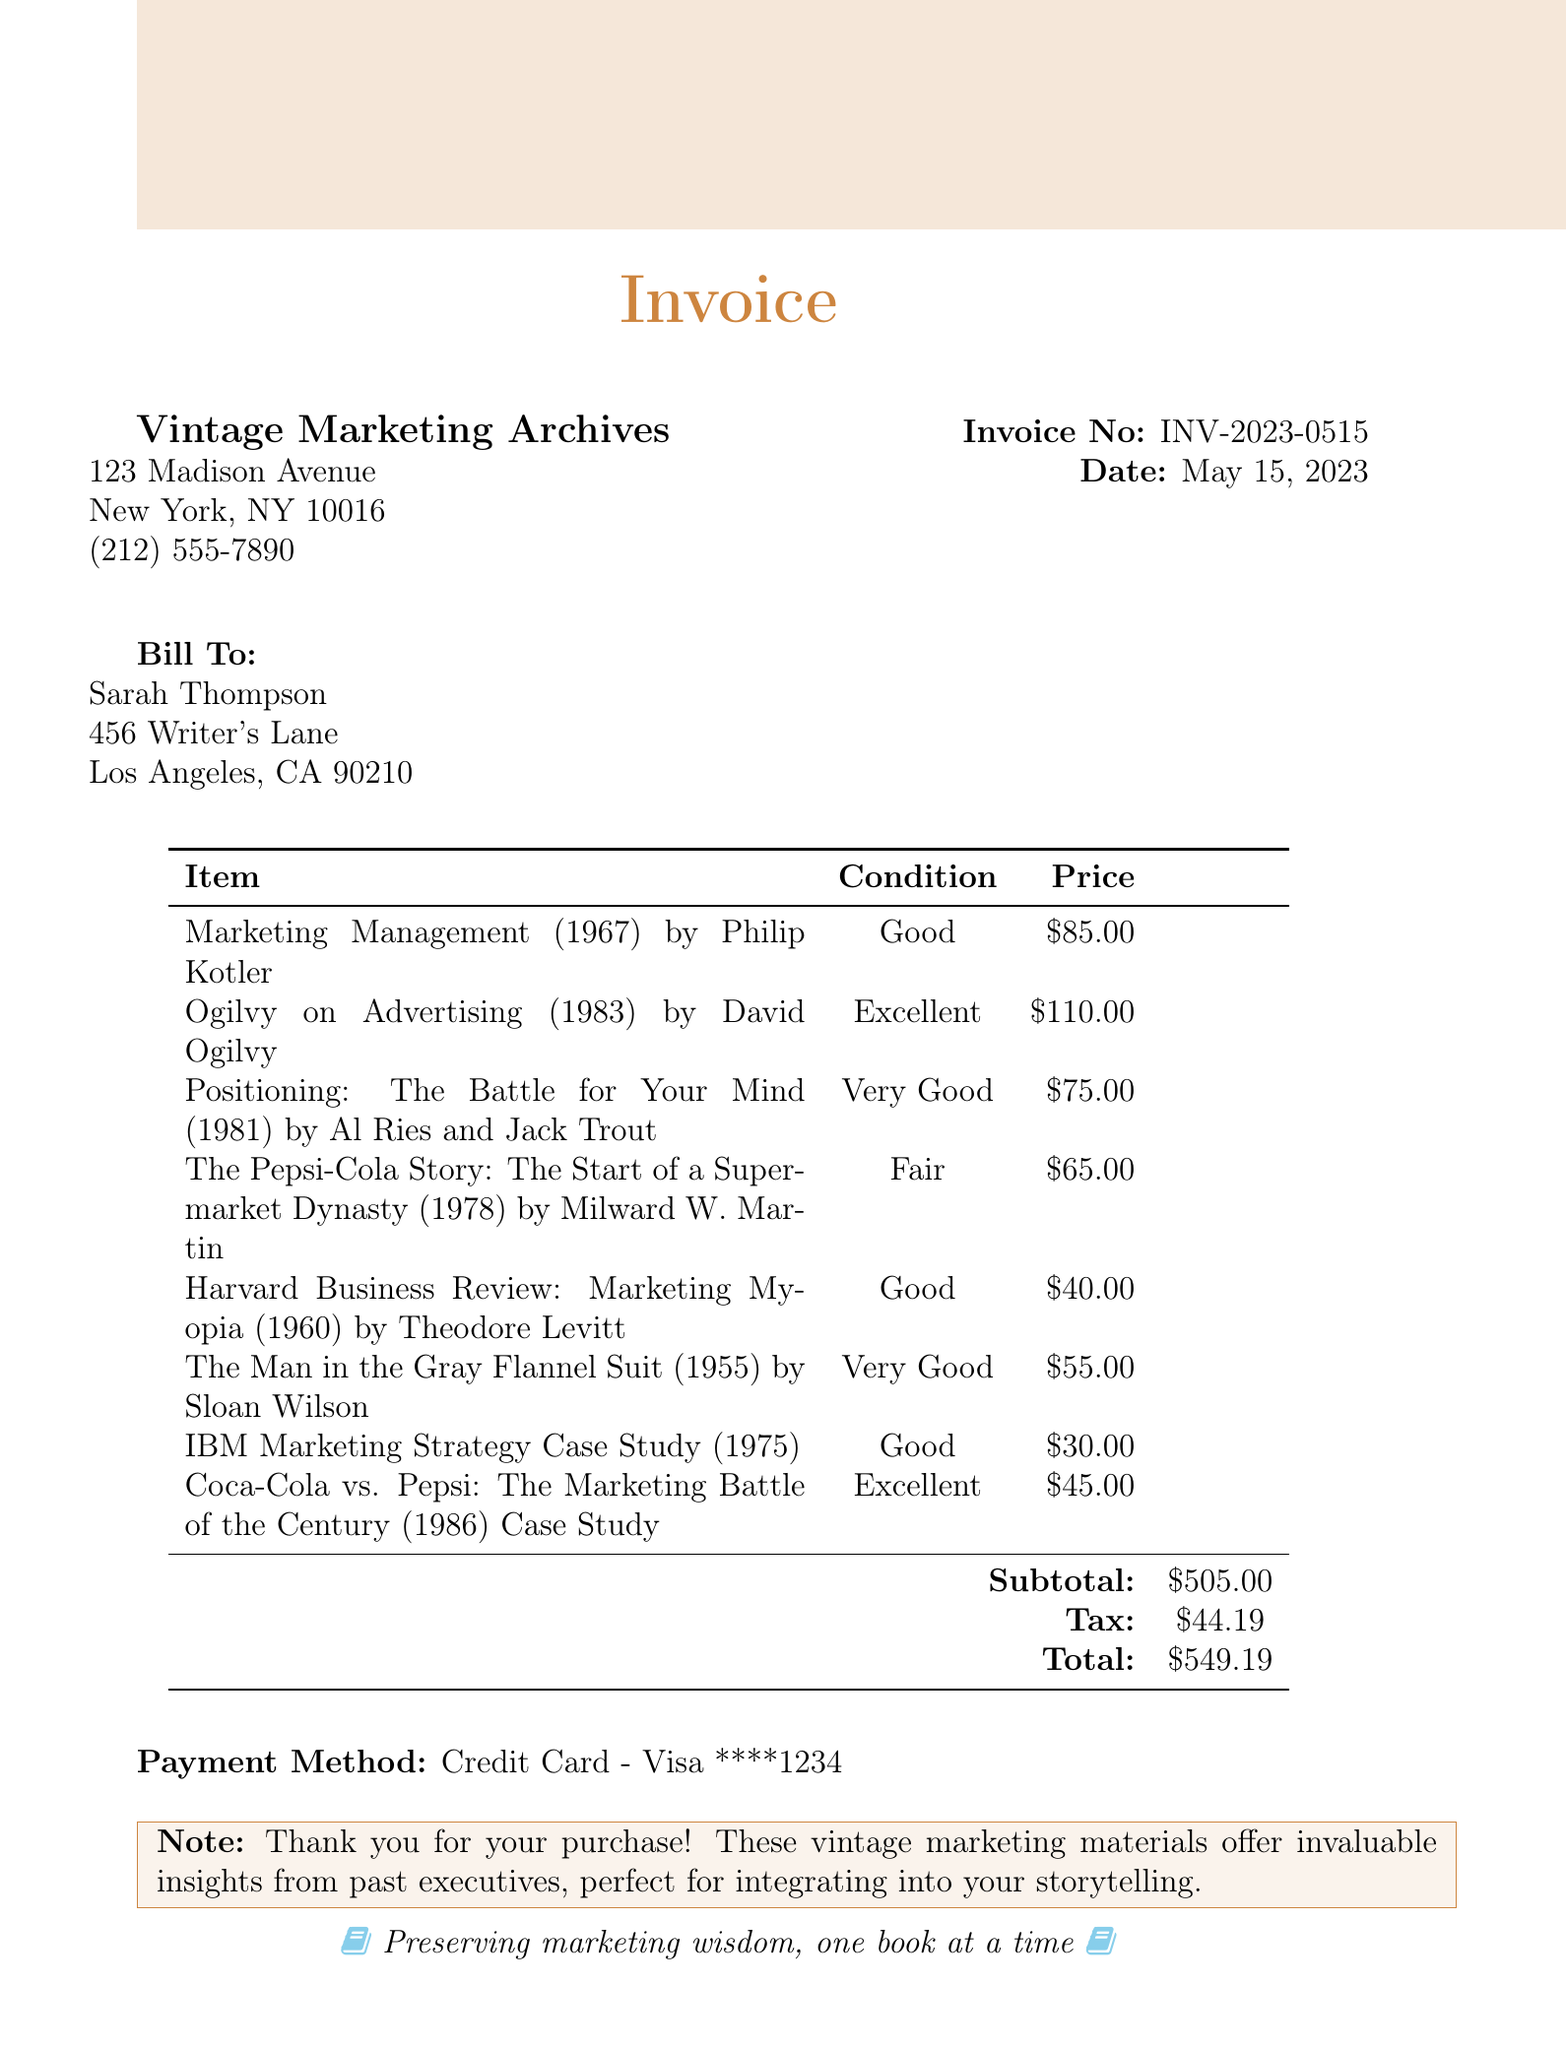What is the store name? The store name is listed at the top of the document under the invoice details.
Answer: Vintage Marketing Archives What is the invoice number? The invoice number is provided in the header section of the document.
Answer: INV-2023-0515 Who is the customer? The customer's name is mentioned in the billing section of the document.
Answer: Sarah Thompson What is the subtotal amount? The subtotal amount is indicated in the pricing table towards the bottom of the document.
Answer: $505.00 What is the tax amount? The tax amount is specified in the pricing table, under the subtotal.
Answer: $44.19 Which book has the highest price? The book with the highest price can be determined by comparing the prices listed in the itemized section.
Answer: Ogilvy on Advertising (1983) by David Ogilvy How many items were purchased? The total number of items is calculated from the list provided in the document.
Answer: 8 What is the payment method? The payment method is stated towards the end of the document.
Answer: Credit Card - Visa ****1234 What is the total amount paid? The total amount is the final sum calculated in the pricing section of the document.
Answer: $549.19 